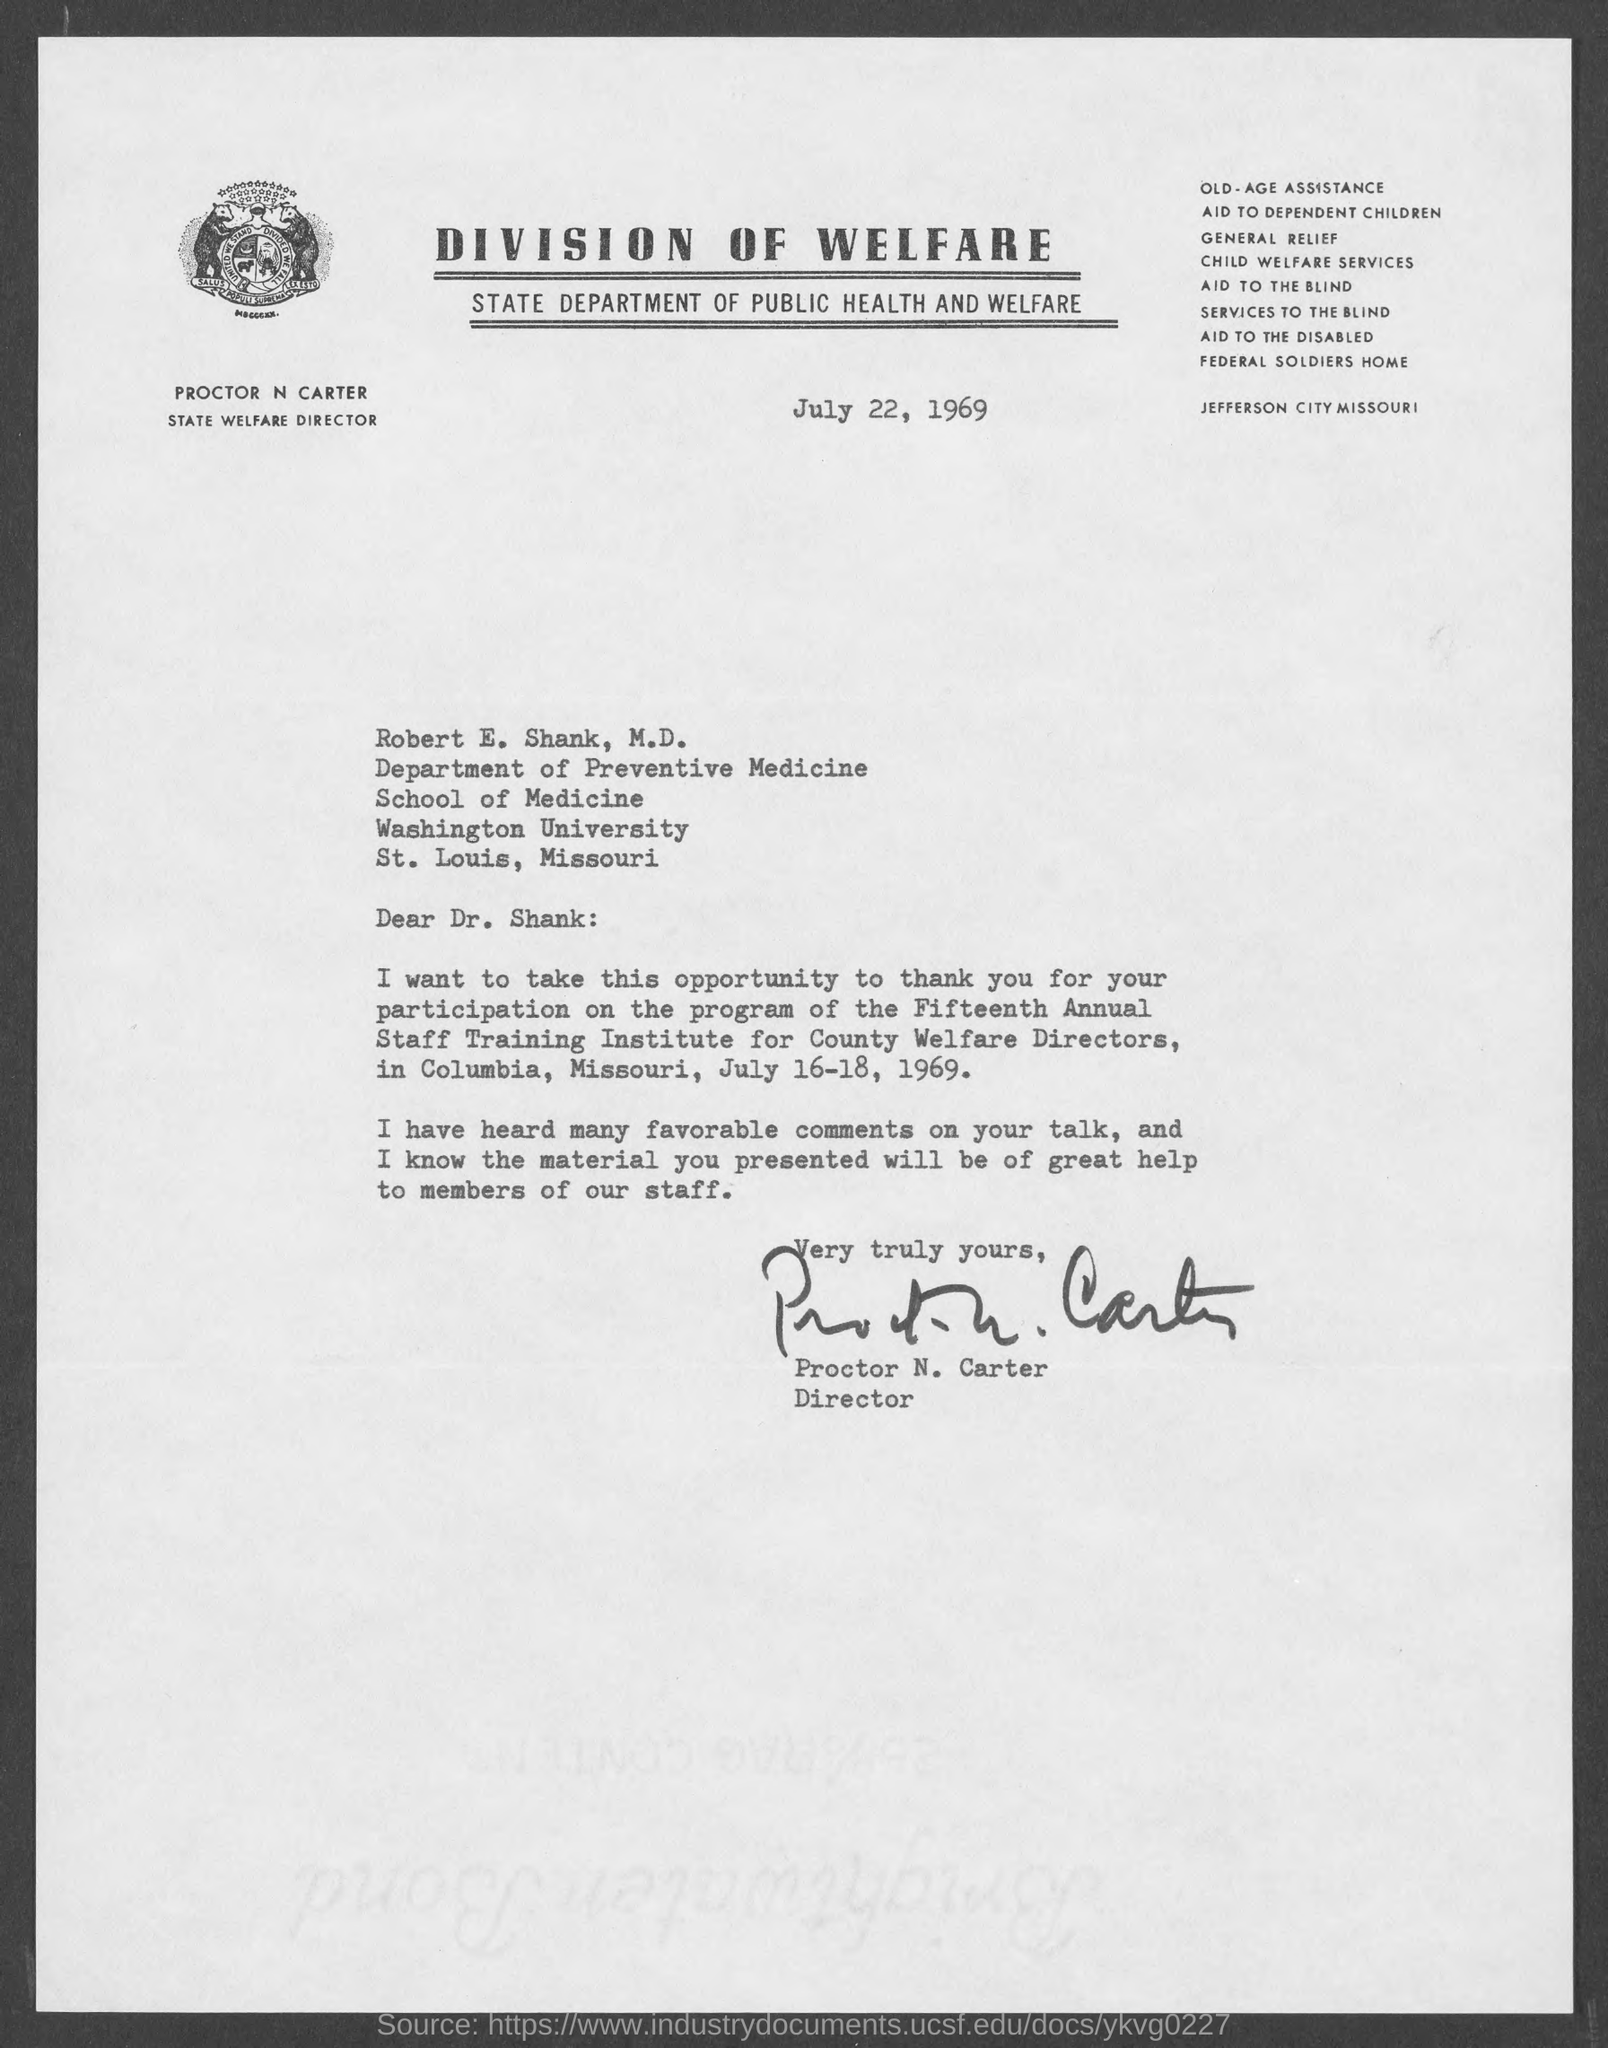Point out several critical features in this image. The issued date of this letter is July 22, 1969. The letter has been signed by Proctor N. Carter. The program of the Fifteenth Annual Staff Training Institute for County Welfare Directors was held from July 16 to 18, 1969. 